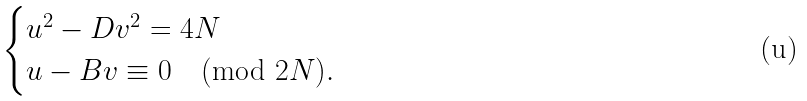<formula> <loc_0><loc_0><loc_500><loc_500>\begin{cases} u ^ { 2 } - D v ^ { 2 } = 4 N \\ u - B v \equiv 0 \pmod { 2 N } . \end{cases}</formula> 